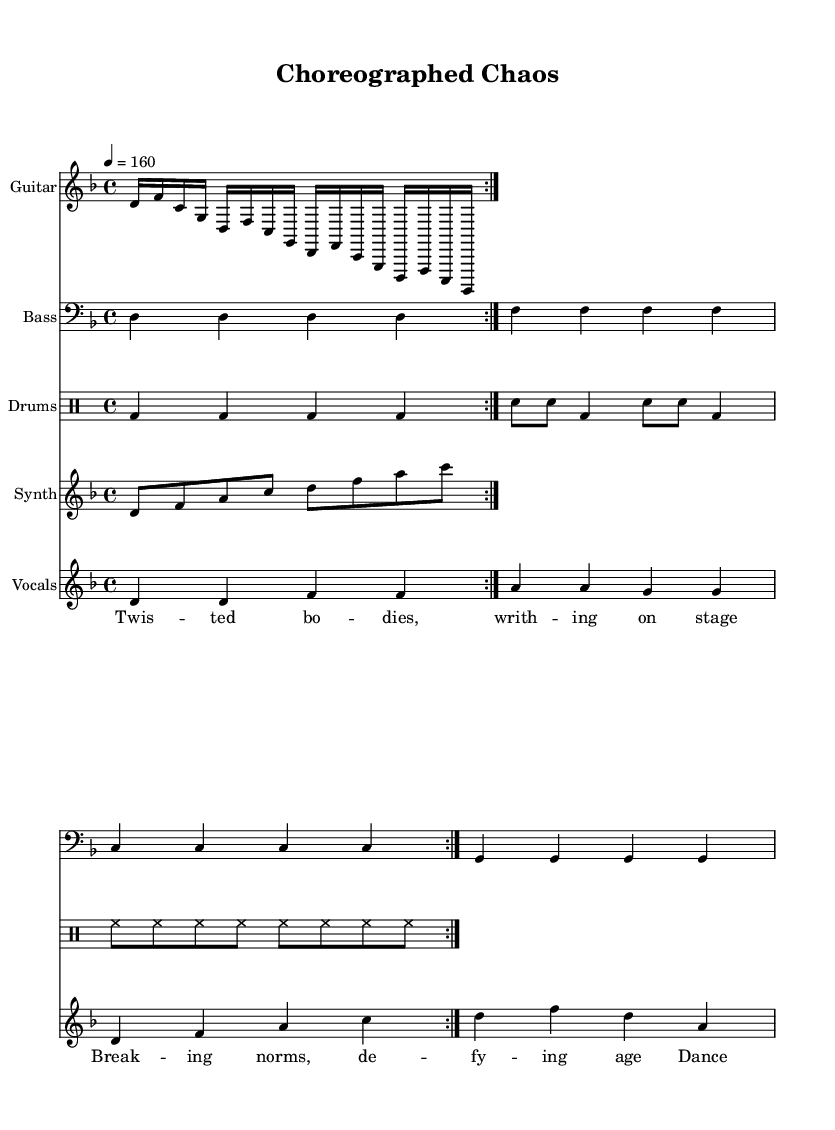What is the key signature of this music? The key signature indicates two flats, which means the piece is in D minor. In D minor, B♭ and E♭ are flattened.
Answer: D minor What is the time signature of this music? The time signature is indicated at the beginning of the score and shows that the piece is in quadruple meter, specifically 4 beats per measure.
Answer: 4/4 What is the tempo marking for this music? The tempo marking can be found in the score, indicating the speed of the piece, which is set at 160 beats per minute.
Answer: 160 How many measures are in the guitar riff? By counting the repetitions and breakdown of the guitar riff section in the score, we see it consists of 4 measures in total.
Answer: 4 What genre is this piece primarily classified under? The combination of heavy guitar riffs, driving rhythms, and thematic lyrics suggests the piece falls under the industrial metal genre.
Answer: Industrial metal How many times is the verse repeated in the score? The repetition in the vocal section indicates that the verse is played twice, as marked in the score.
Answer: 2 What lyrics are featured in the chorus? The lyrics featured in the chorus are declared in the score, specifying that it addresses the evolution of dance as art or madness.
Answer: Dance evolves, society reels 